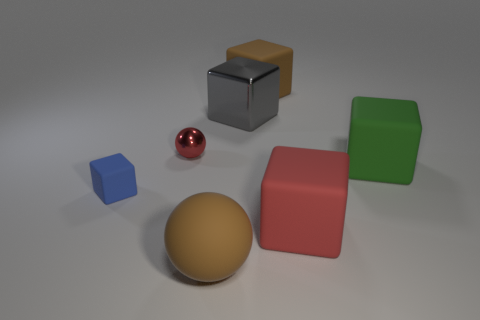Subtract all blue blocks. How many blocks are left? 4 Subtract all blue matte cubes. How many cubes are left? 4 Subtract 1 cubes. How many cubes are left? 4 Subtract all cyan blocks. Subtract all gray balls. How many blocks are left? 5 Add 1 small objects. How many objects exist? 8 Subtract all balls. How many objects are left? 5 Subtract all large green rubber cylinders. Subtract all big matte cubes. How many objects are left? 4 Add 5 red objects. How many red objects are left? 7 Add 2 big gray balls. How many big gray balls exist? 2 Subtract 1 green cubes. How many objects are left? 6 